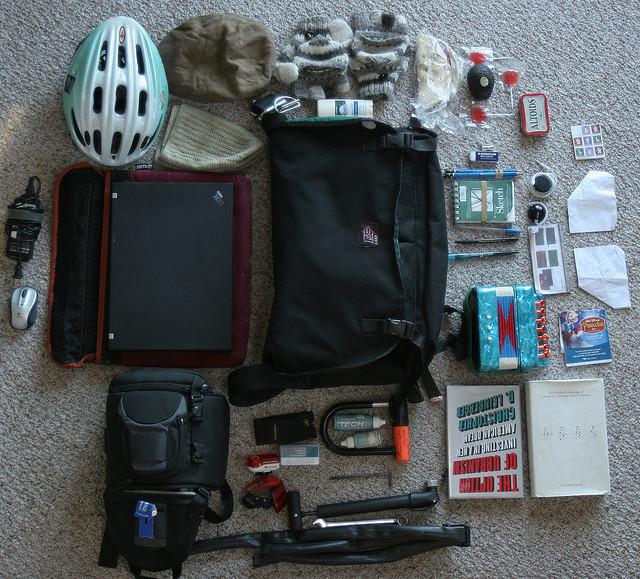Is there anything someone would wear on their head?
Write a very short answer. Yes. Do you see a computer mouse?
Be succinct. Yes. Will all this items fit in the backpack?
Be succinct. Yes. What color are the gloves?
Short answer required. Gray. Would this be a typical first aid kit for a home?
Answer briefly. No. 